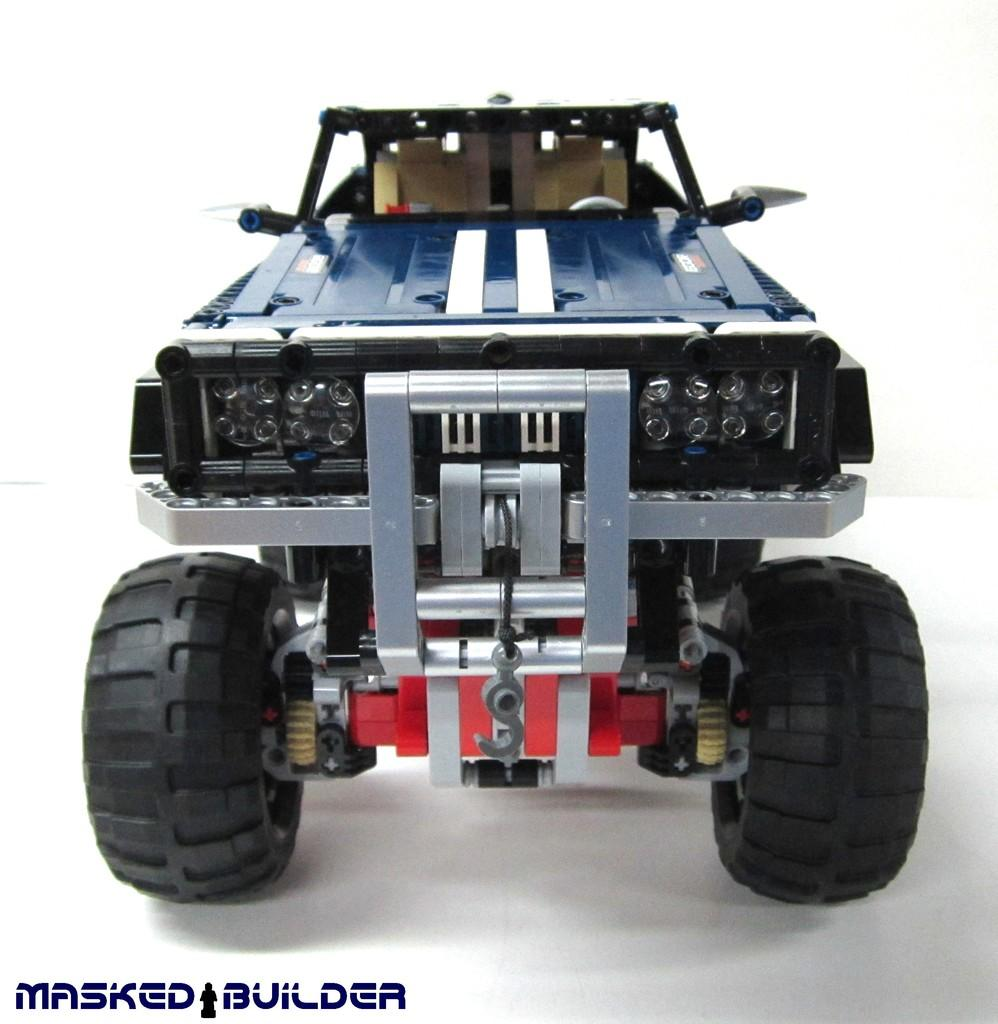What is the main subject of the image? There is a depiction of a car in the center of the image. Where is the cactus located in the image? There is no cactus present in the image. What type of yarn is being used to create the car in the image? The image is a depiction of a car, not a yarn creation, so there is no yarn involved. 